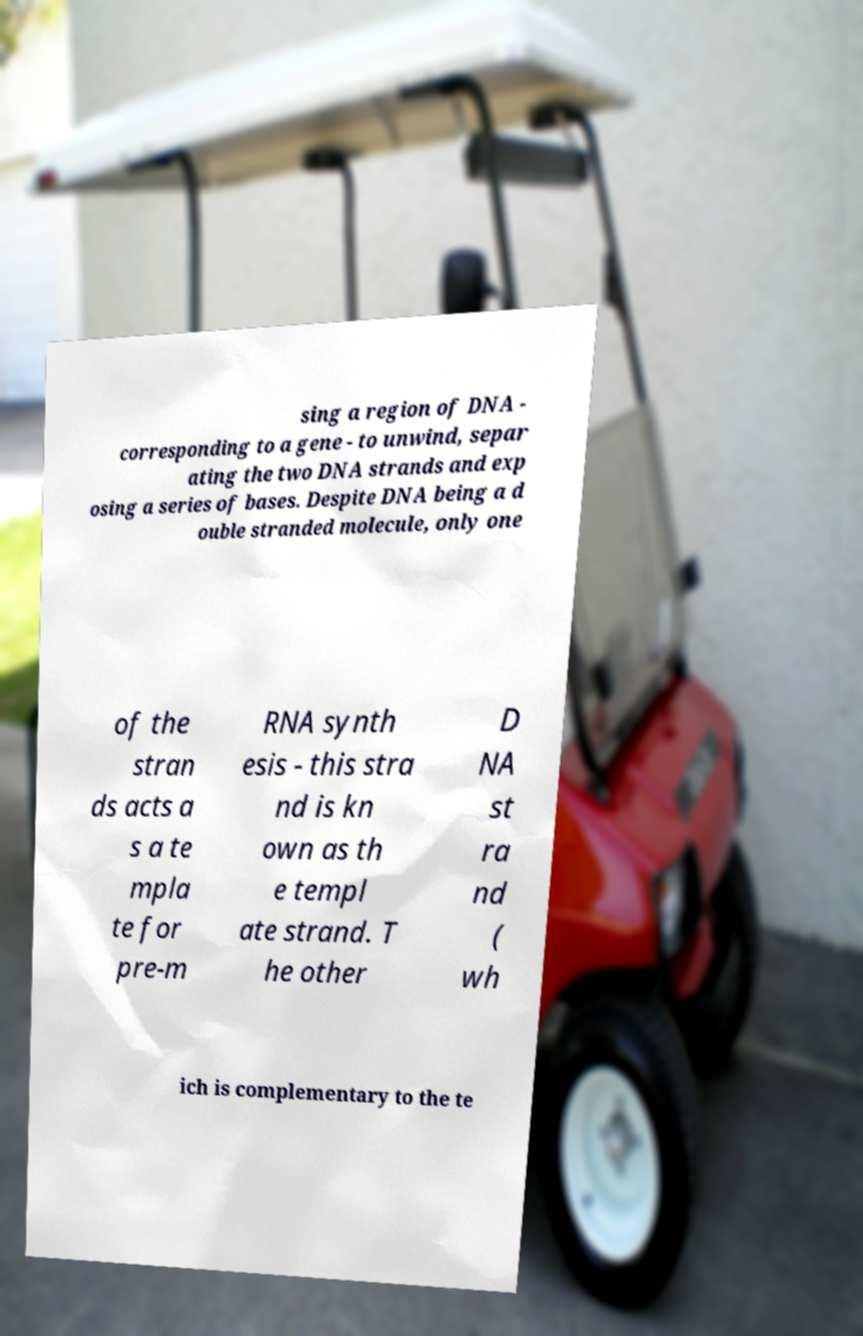What messages or text are displayed in this image? I need them in a readable, typed format. sing a region of DNA - corresponding to a gene - to unwind, separ ating the two DNA strands and exp osing a series of bases. Despite DNA being a d ouble stranded molecule, only one of the stran ds acts a s a te mpla te for pre-m RNA synth esis - this stra nd is kn own as th e templ ate strand. T he other D NA st ra nd ( wh ich is complementary to the te 